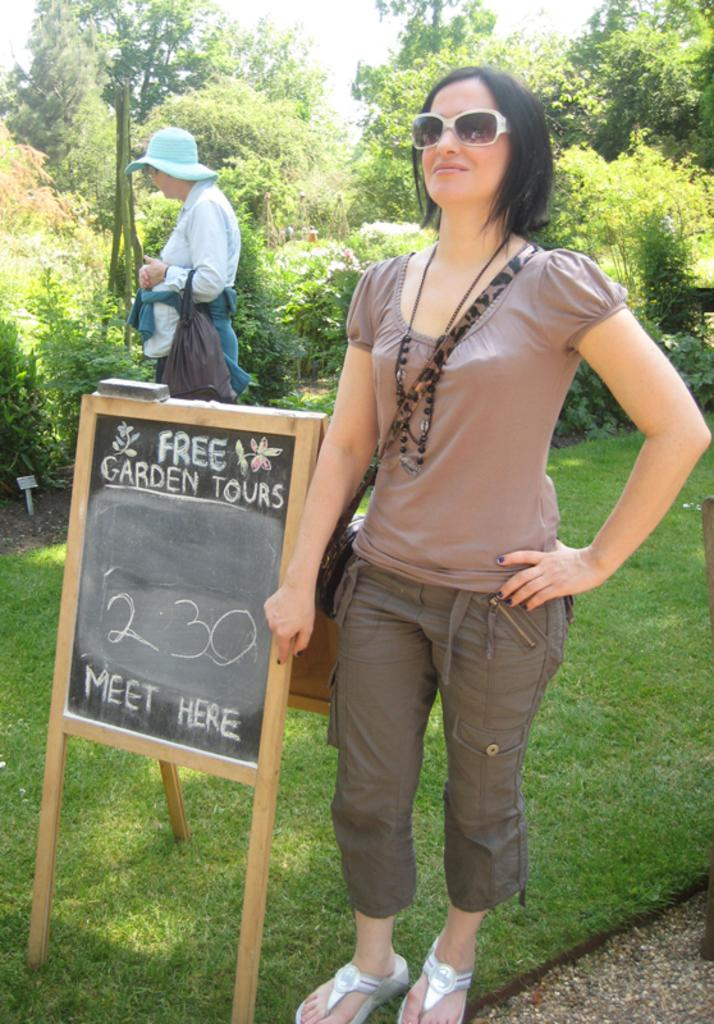What is the primary subject of the image? There is a woman standing in the image. What is located on the grass in the image? There is a board on the grass in the image. Are there any other people in the image besides the woman? Yes, there is another person standing in the image. What can be seen in the background of the image? There are trees in the background of the image. What type of drug is the woman holding in the image? There is no drug present in the image; the woman is not holding anything. How does the woman balance on the board in the image? The image does not show the woman balancing on the board, so it is not possible to determine how she might be balancing. 